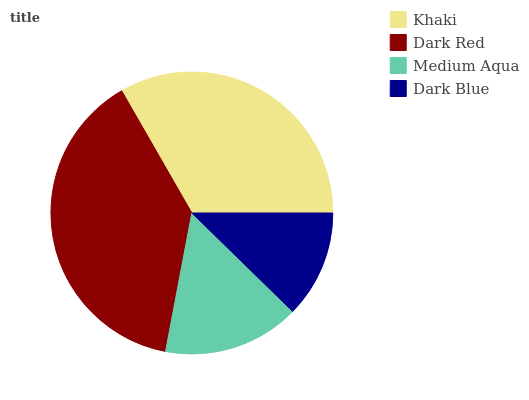Is Dark Blue the minimum?
Answer yes or no. Yes. Is Dark Red the maximum?
Answer yes or no. Yes. Is Medium Aqua the minimum?
Answer yes or no. No. Is Medium Aqua the maximum?
Answer yes or no. No. Is Dark Red greater than Medium Aqua?
Answer yes or no. Yes. Is Medium Aqua less than Dark Red?
Answer yes or no. Yes. Is Medium Aqua greater than Dark Red?
Answer yes or no. No. Is Dark Red less than Medium Aqua?
Answer yes or no. No. Is Khaki the high median?
Answer yes or no. Yes. Is Medium Aqua the low median?
Answer yes or no. Yes. Is Medium Aqua the high median?
Answer yes or no. No. Is Dark Blue the low median?
Answer yes or no. No. 